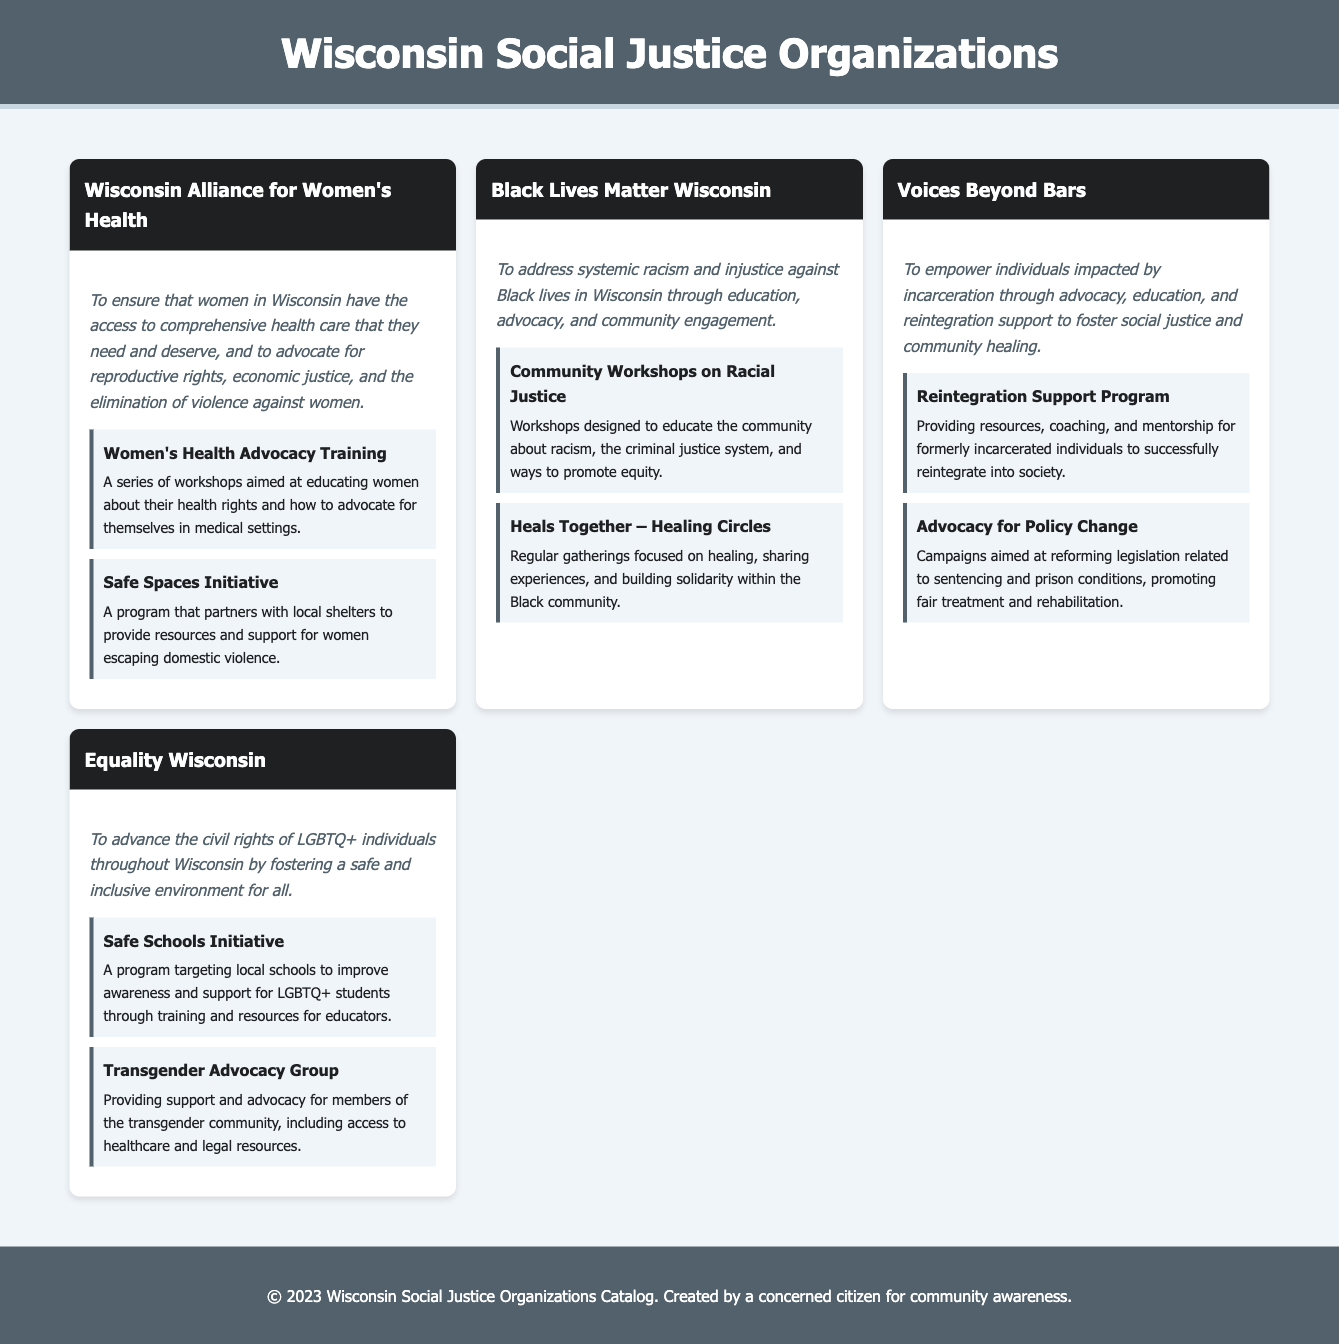What is the mission of Wisconsin Alliance for Women's Health? The mission is to ensure that women in Wisconsin have the access to comprehensive health care that they need and deserve, and to advocate for reproductive rights, economic justice, and the elimination of violence against women.
Answer: To ensure that women in Wisconsin have the access to comprehensive health care that they need and deserve, and to advocate for reproductive rights, economic justice, and the elimination of violence against women How many community projects does Black Lives Matter Wisconsin have listed? The document lists two community projects under Black Lives Matter Wisconsin.
Answer: 2 What is the focus of the Safe Schools Initiative? The focus of the Safe Schools Initiative is to improve awareness and support for LGBTQ+ students through training and resources for educators.
Answer: To improve awareness and support for LGBTQ+ students through training and resources for educators Name one project from Voices Beyond Bars. One project from Voices Beyond Bars is the Reintegration Support Program.
Answer: Reintegration Support Program What does Equality Wisconsin aim to advance? Equality Wisconsin aims to advance the civil rights of LGBTQ+ individuals throughout Wisconsin.
Answer: The civil rights of LGBTQ+ individuals throughout Wisconsin Which organization focuses on advocacy for transgender individuals? The organization that focuses on advocacy for transgender individuals is Equality Wisconsin.
Answer: Equality Wisconsin What kind of program is the Heals Together – Healing Circles? The Heals Together – Healing Circles is a program that focuses on healing, sharing experiences, and building solidarity within the Black community.
Answer: A program that focuses on healing, sharing experiences, and building solidarity within the Black community 